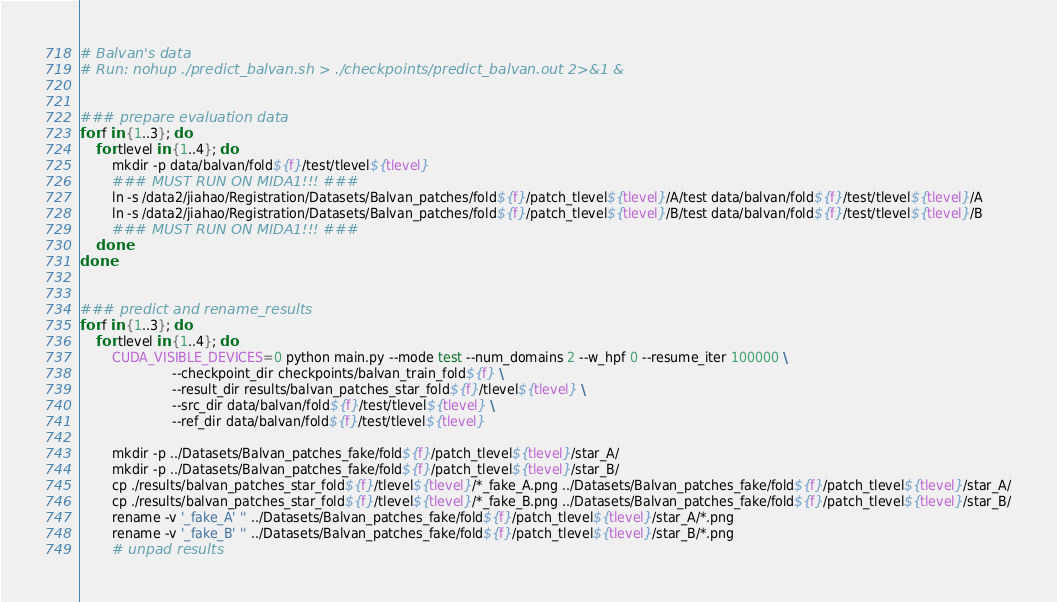<code> <loc_0><loc_0><loc_500><loc_500><_Bash_># Balvan's data
# Run: nohup ./predict_balvan.sh > ./checkpoints/predict_balvan.out 2>&1 &


### prepare evaluation data
for f in {1..3}; do
	for tlevel in {1..4}; do
		mkdir -p data/balvan/fold${f}/test/tlevel${tlevel}
		### MUST RUN ON MIDA1!!! ###
		ln -s /data2/jiahao/Registration/Datasets/Balvan_patches/fold${f}/patch_tlevel${tlevel}/A/test data/balvan/fold${f}/test/tlevel${tlevel}/A
		ln -s /data2/jiahao/Registration/Datasets/Balvan_patches/fold${f}/patch_tlevel${tlevel}/B/test data/balvan/fold${f}/test/tlevel${tlevel}/B
		### MUST RUN ON MIDA1!!! ###
	done
done


### predict and rename_results
for f in {1..3}; do
	for tlevel in {1..4}; do
		CUDA_VISIBLE_DEVICES=0 python main.py --mode test --num_domains 2 --w_hpf 0 --resume_iter 100000 \
		               --checkpoint_dir checkpoints/balvan_train_fold${f} \
		               --result_dir results/balvan_patches_star_fold${f}/tlevel${tlevel} \
		               --src_dir data/balvan/fold${f}/test/tlevel${tlevel} \
		               --ref_dir data/balvan/fold${f}/test/tlevel${tlevel}

		mkdir -p ../Datasets/Balvan_patches_fake/fold${f}/patch_tlevel${tlevel}/star_A/
		mkdir -p ../Datasets/Balvan_patches_fake/fold${f}/patch_tlevel${tlevel}/star_B/
		cp ./results/balvan_patches_star_fold${f}/tlevel${tlevel}/*_fake_A.png ../Datasets/Balvan_patches_fake/fold${f}/patch_tlevel${tlevel}/star_A/
		cp ./results/balvan_patches_star_fold${f}/tlevel${tlevel}/*_fake_B.png ../Datasets/Balvan_patches_fake/fold${f}/patch_tlevel${tlevel}/star_B/
		rename -v '_fake_A' '' ../Datasets/Balvan_patches_fake/fold${f}/patch_tlevel${tlevel}/star_A/*.png
		rename -v '_fake_B' '' ../Datasets/Balvan_patches_fake/fold${f}/patch_tlevel${tlevel}/star_B/*.png
		# unpad results</code> 